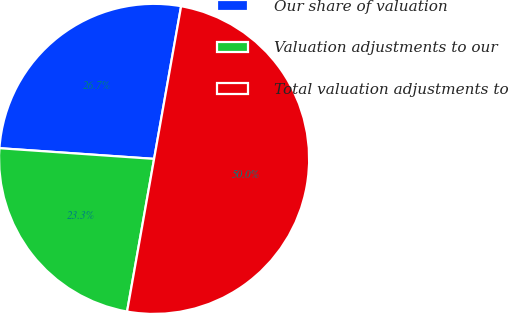Convert chart. <chart><loc_0><loc_0><loc_500><loc_500><pie_chart><fcel>Our share of valuation<fcel>Valuation adjustments to our<fcel>Total valuation adjustments to<nl><fcel>26.69%<fcel>23.31%<fcel>50.0%<nl></chart> 